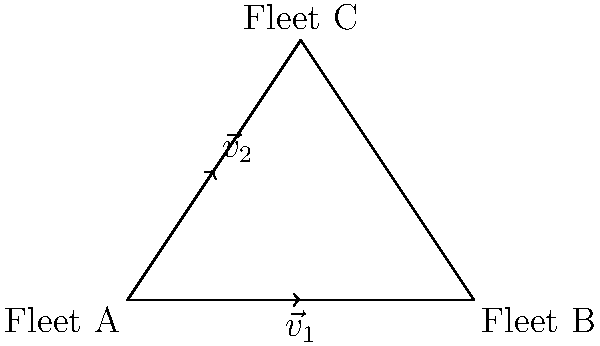In a naval strategic positioning exercise, three fleets (A, B, and C) form a triangular formation. Fleet A is located at the origin, Fleet B is 4 units east, and Fleet C is 2 units east and 3 units north of Fleet A. Two vectors, $\vec{v}_1$ and $\vec{v}_2$, represent potential movement directions for Fleet A. If $\vec{v}_1 = 2\hat{i}$ and $\vec{v}_2 = \hat{i} + 1.5\hat{j}$, what is the magnitude of the resultant vector if Fleet A moves along both vectors simultaneously? To find the magnitude of the resultant vector when Fleet A moves along both $\vec{v}_1$ and $\vec{v}_2$ simultaneously, we need to follow these steps:

1. Identify the components of each vector:
   $\vec{v}_1 = 2\hat{i}$
   $\vec{v}_2 = \hat{i} + 1.5\hat{j}$

2. Add the vectors to find the resultant vector $\vec{R}$:
   $\vec{R} = \vec{v}_1 + \vec{v}_2 = (2\hat{i}) + (\hat{i} + 1.5\hat{j})$
   $\vec{R} = 3\hat{i} + 1.5\hat{j}$

3. Calculate the magnitude of the resultant vector using the Pythagorean theorem:
   $|\vec{R}| = \sqrt{(3)^2 + (1.5)^2}$
   $|\vec{R}| = \sqrt{9 + 2.25}$
   $|\vec{R}| = \sqrt{11.25}$
   $|\vec{R}| = 3.354$ (rounded to three decimal places)

Therefore, the magnitude of the resultant vector when Fleet A moves along both $\vec{v}_1$ and $\vec{v}_2$ simultaneously is approximately 3.354 units.
Answer: $3.354$ units 